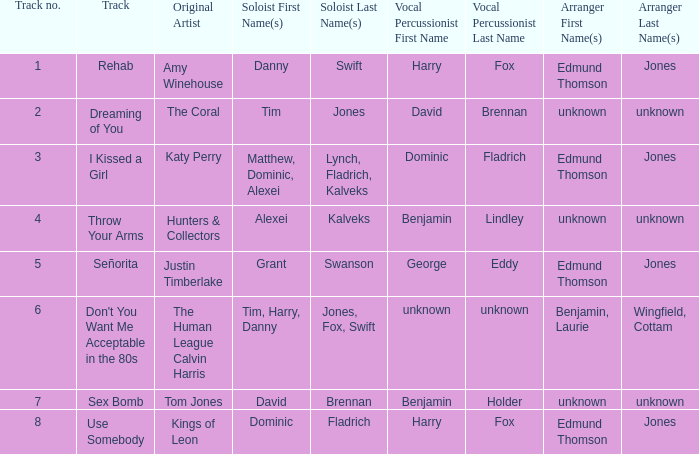Who is the artist where the vocal percussionist is Benjamin Holder? Tom Jones. 